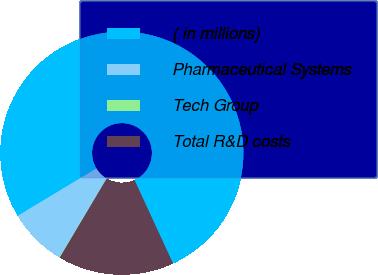Convert chart to OTSL. <chart><loc_0><loc_0><loc_500><loc_500><pie_chart><fcel>( in millions)<fcel>Pharmaceutical Systems<fcel>Tech Group<fcel>Total R&D costs<nl><fcel>76.76%<fcel>7.75%<fcel>0.08%<fcel>15.42%<nl></chart> 